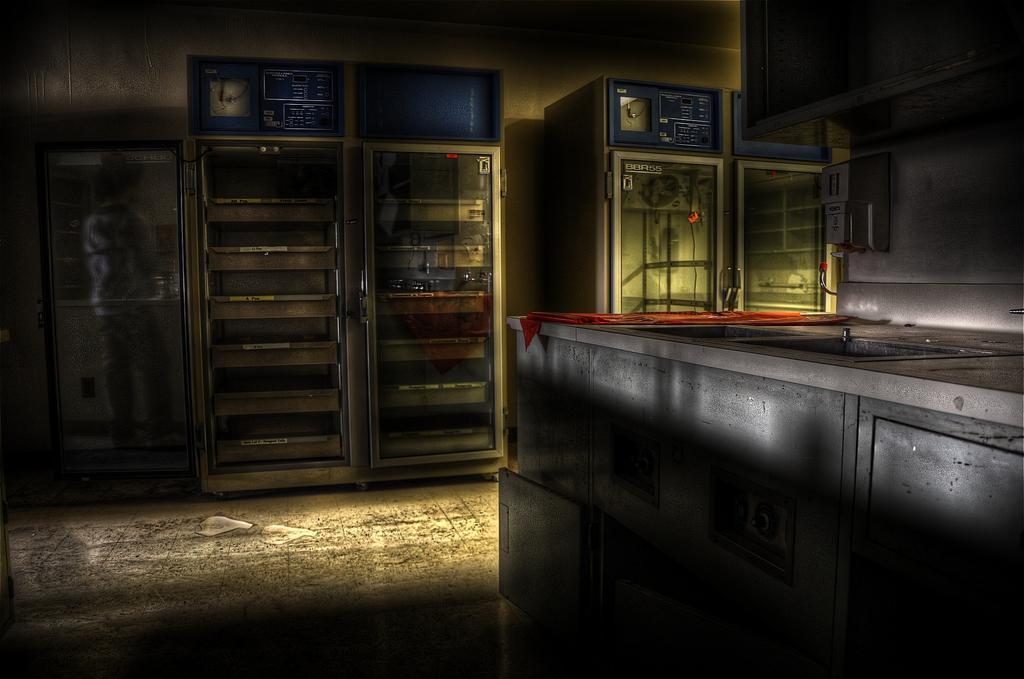Can you describe this image briefly? In a room there is a big table and beside that there are four empty refrigerators,in the left side there is a door and behind the door there is a person. 